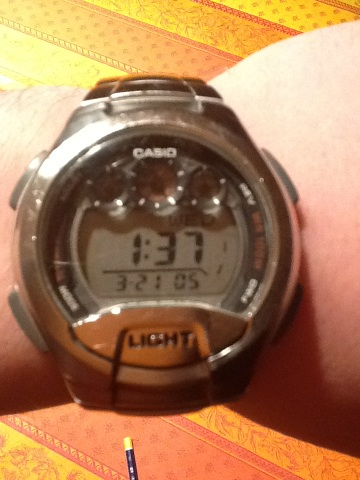What time is it? Based on the digital display of the Casio watch in the image, it appears to be 1:37. You can also notice that the date displayed is 3-21 so it's likely March 21st. 